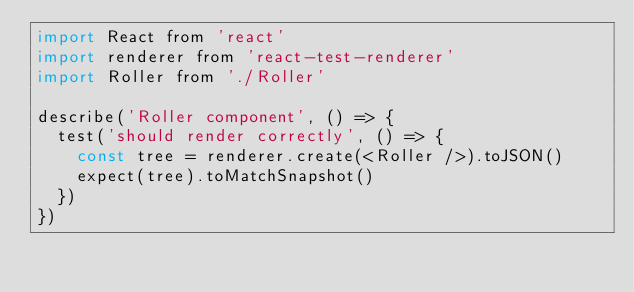<code> <loc_0><loc_0><loc_500><loc_500><_JavaScript_>import React from 'react'
import renderer from 'react-test-renderer'
import Roller from './Roller'

describe('Roller component', () => {
  test('should render correctly', () => {
    const tree = renderer.create(<Roller />).toJSON()
    expect(tree).toMatchSnapshot()
  })
})
</code> 